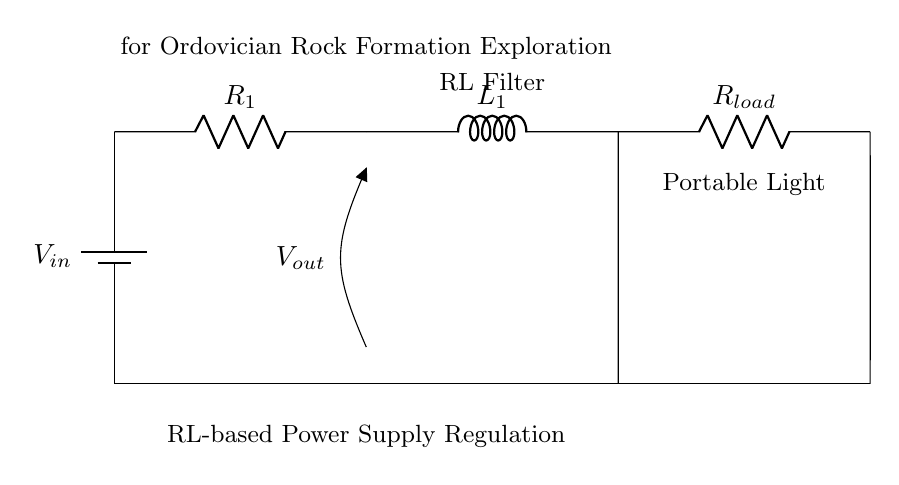What is the type of the circuit shown? The circuit consists of resistors and an inductor, which indicates that it is a Resistor-Inductor circuit.
Answer: Resistor-Inductor What components are connected in series? The battery, resistor R1, and inductor L1 are all connected in series, indicating that the same current flows through them without any branching.
Answer: Battery, R1, L1 What is the function of R_load in the circuit? R_load is the load resistor that provides power to the portable light, helping to regulate the voltage supplied to it.
Answer: Load resistor What is the purpose of the inductor L1 in this circuit? The inductor L1 smooths out the fluctuations in current, providing a stable output voltage for the connected load.
Answer: Smooth current fluctuations How does the output voltage relate to input voltage and resistance values? The output voltage is influenced by the input voltage and the combined resistance and inductance in the circuit according to the voltage divider rule, leading to a reduced voltage at V_out based on the load characteristics.
Answer: Depends on input voltage and resistance values What is the expected behavior of V_out during sudden load changes? V_out will initially drop or spike before stabilizing due to the inductor's property of opposing changes in current, which affects the immediate response of the circuit to load variations.
Answer: Initial instability before stabilization 